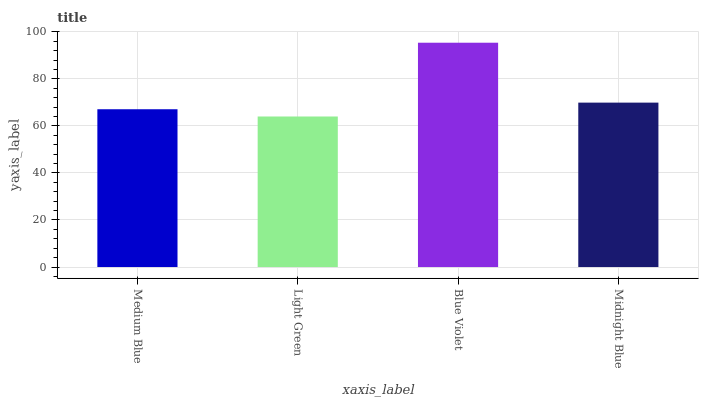Is Light Green the minimum?
Answer yes or no. Yes. Is Blue Violet the maximum?
Answer yes or no. Yes. Is Blue Violet the minimum?
Answer yes or no. No. Is Light Green the maximum?
Answer yes or no. No. Is Blue Violet greater than Light Green?
Answer yes or no. Yes. Is Light Green less than Blue Violet?
Answer yes or no. Yes. Is Light Green greater than Blue Violet?
Answer yes or no. No. Is Blue Violet less than Light Green?
Answer yes or no. No. Is Midnight Blue the high median?
Answer yes or no. Yes. Is Medium Blue the low median?
Answer yes or no. Yes. Is Light Green the high median?
Answer yes or no. No. Is Light Green the low median?
Answer yes or no. No. 